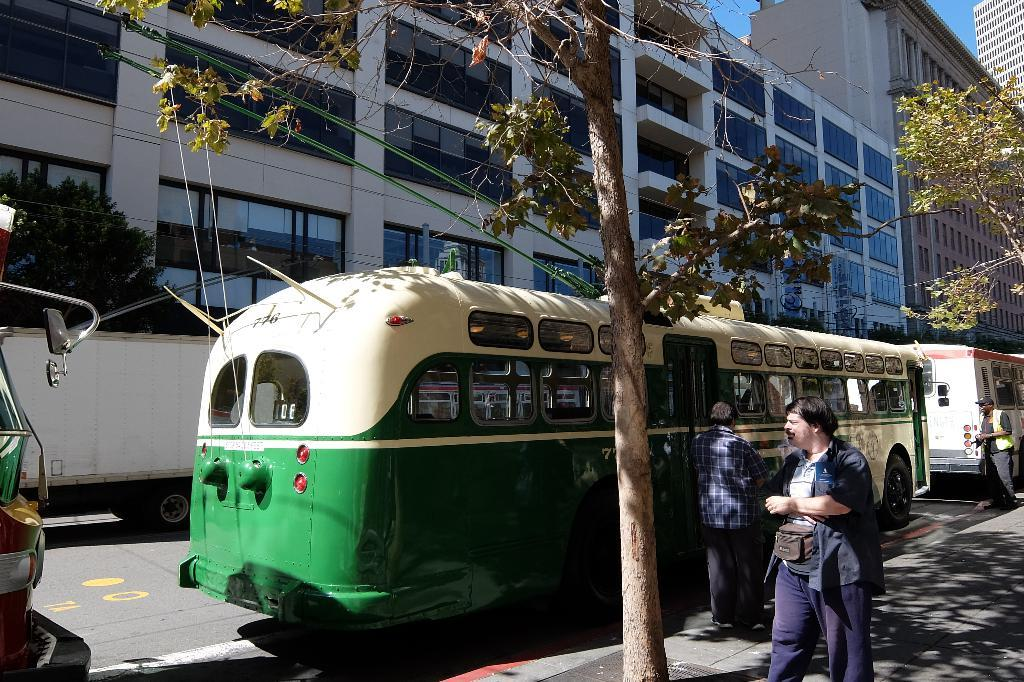What can be seen on the road in the image? There are vehicles on the road in the image. What type of natural elements are visible in the image? There are trees visible in the image. What type of structures can be seen in the image? There are buildings with windows in the image. Where are the persons located in the image? The persons are on a footpath in the image. What is visible in the background of the image? The sky is visible in the background of the image. How many trains are visible in the image? There are no trains visible in the image. What is the amount of water flowing in the stream in the image? There is no stream present in the image. 